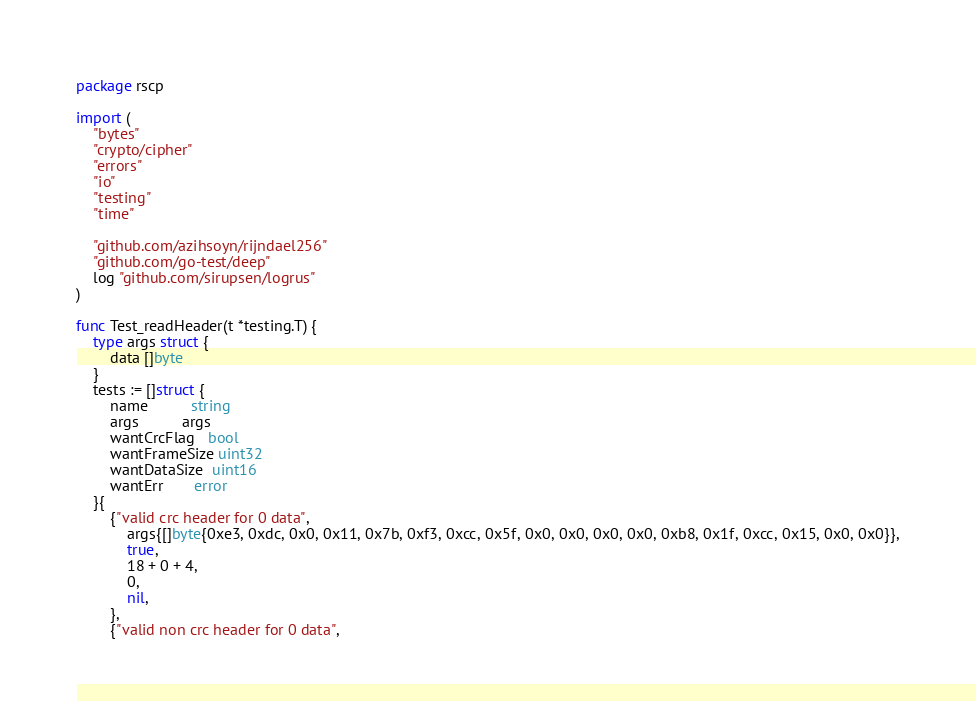Convert code to text. <code><loc_0><loc_0><loc_500><loc_500><_Go_>package rscp

import (
	"bytes"
	"crypto/cipher"
	"errors"
	"io"
	"testing"
	"time"

	"github.com/azihsoyn/rijndael256"
	"github.com/go-test/deep"
	log "github.com/sirupsen/logrus"
)

func Test_readHeader(t *testing.T) {
	type args struct {
		data []byte
	}
	tests := []struct {
		name          string
		args          args
		wantCrcFlag   bool
		wantFrameSize uint32
		wantDataSize  uint16
		wantErr       error
	}{
		{"valid crc header for 0 data",
			args{[]byte{0xe3, 0xdc, 0x0, 0x11, 0x7b, 0xf3, 0xcc, 0x5f, 0x0, 0x0, 0x0, 0x0, 0xb8, 0x1f, 0xcc, 0x15, 0x0, 0x0}},
			true,
			18 + 0 + 4,
			0,
			nil,
		},
		{"valid non crc header for 0 data",</code> 